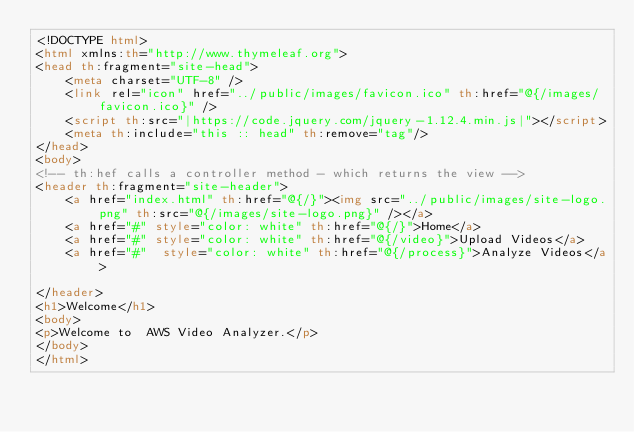<code> <loc_0><loc_0><loc_500><loc_500><_HTML_><!DOCTYPE html>
<html xmlns:th="http://www.thymeleaf.org">
<head th:fragment="site-head">
    <meta charset="UTF-8" />
    <link rel="icon" href="../public/images/favicon.ico" th:href="@{/images/favicon.ico}" />
    <script th:src="|https://code.jquery.com/jquery-1.12.4.min.js|"></script>
    <meta th:include="this :: head" th:remove="tag"/>
</head>
<body>
<!-- th:hef calls a controller method - which returns the view -->
<header th:fragment="site-header">
    <a href="index.html" th:href="@{/}"><img src="../public/images/site-logo.png" th:src="@{/images/site-logo.png}" /></a>
    <a href="#" style="color: white" th:href="@{/}">Home</a>
    <a href="#" style="color: white" th:href="@{/video}">Upload Videos</a>
    <a href="#"  style="color: white" th:href="@{/process}">Analyze Videos</a>

</header>
<h1>Welcome</h1>
<body>
<p>Welcome to  AWS Video Analyzer.</p>
</body>
</html></code> 